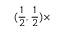Convert formula to latex. <formula><loc_0><loc_0><loc_500><loc_500>( \frac { 1 } { 2 } , \frac { 1 } { 2 } ) \times</formula> 